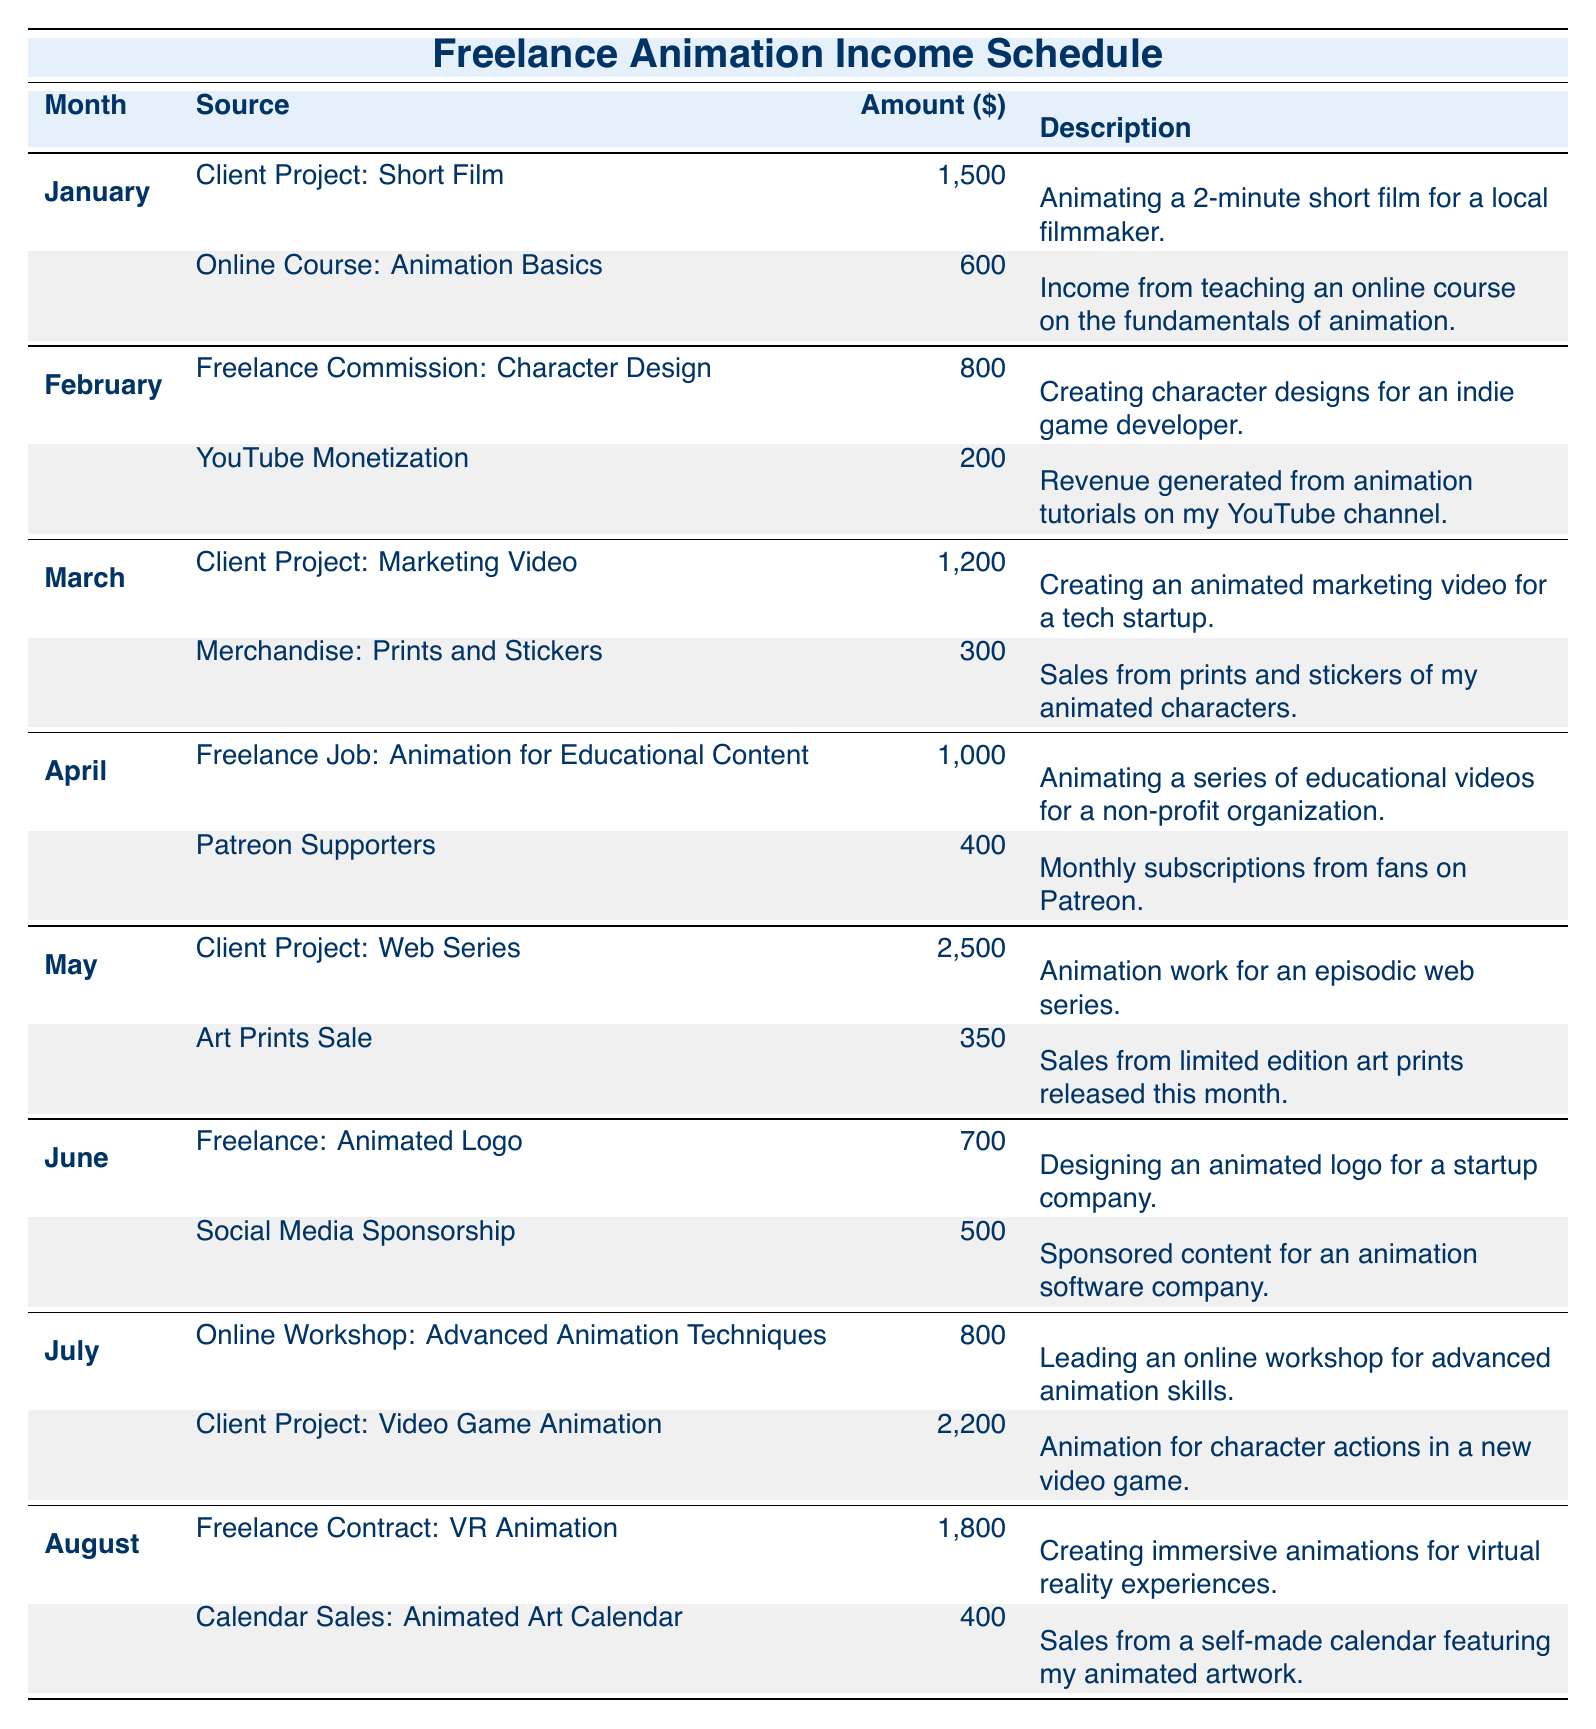What is the total income from January? The income sources for January are the "Client Project: Short Film" with an amount of 1500 and "Online Course: Animation Basics" with 600. Adding them together gives 1500 + 600 = 2100.
Answer: 2100 Which month had the highest income from a single source? The highest single income source is the "Client Project: Web Series" in May with an amount of 2500. Checking each month's highest source reveals that no other source surpasses this amount.
Answer: 2500 Did I earn more in July than in June? The total amount for July is the sum of "Online Workshop: Advanced Animation Techniques" (800) and "Client Project: Video Game Animation" (2200), which totals 3000. For June, I earned 700 and 500 for a total of 1200. Since 3000 is greater than 1200, I earned more in July.
Answer: Yes What was the average income across all months? First, we sum the total amounts from all entries: 1500 + 600 + 800 + 200 + 1200 + 300 + 1000 + 400 + 2500 + 350 + 700 + 500 + 800 + 2200 + 1800 + 400 = 12100. There are 16 income sources, so the average is 12100 / 16 = 756.25.
Answer: 756.25 Is there a month where income was solely generated from client projects? After examining the data, only May has the "Client Project: Web Series" (2500) and "Art Prints Sale" (350), thus it contains income from a non-client source. Checking January (both were project income), February (includes YouTube), March (Merchandise), April (Patreon), June (Freelance and Sponsorship), July (one client project, one workshop), and August (Calendar sales); all months are mixed. So, there is no existence of a month where only client project income was reported.
Answer: No What is the total income from freelance commissions? The freelance commissions are from the following sources: "Freelance Commission: Character Design" (800) in February and "Freelance: Animated Logo" (700) in June, giving us 800 + 700 = 1500.
Answer: 1500 Which month had the least income overall? The monthly income is: January 2100, February 1000, March 1500, April 1400, May 2850, June 1200, July 3000, August 2200. The least income is in February with a total of 1000.
Answer: February What was the total amount generated from merchandise and prints? The total income from merchandise includes "Merchandise: Prints and Stickers" in March (300) and "Art Prints Sale" in May (350), along with "Calendar Sales: Animated Art Calendar" in August (400). Adding these gives 300 + 350 + 400 = 1050.
Answer: 1050 